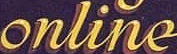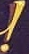What words can you see in these images in sequence, separated by a semicolon? online; ! 